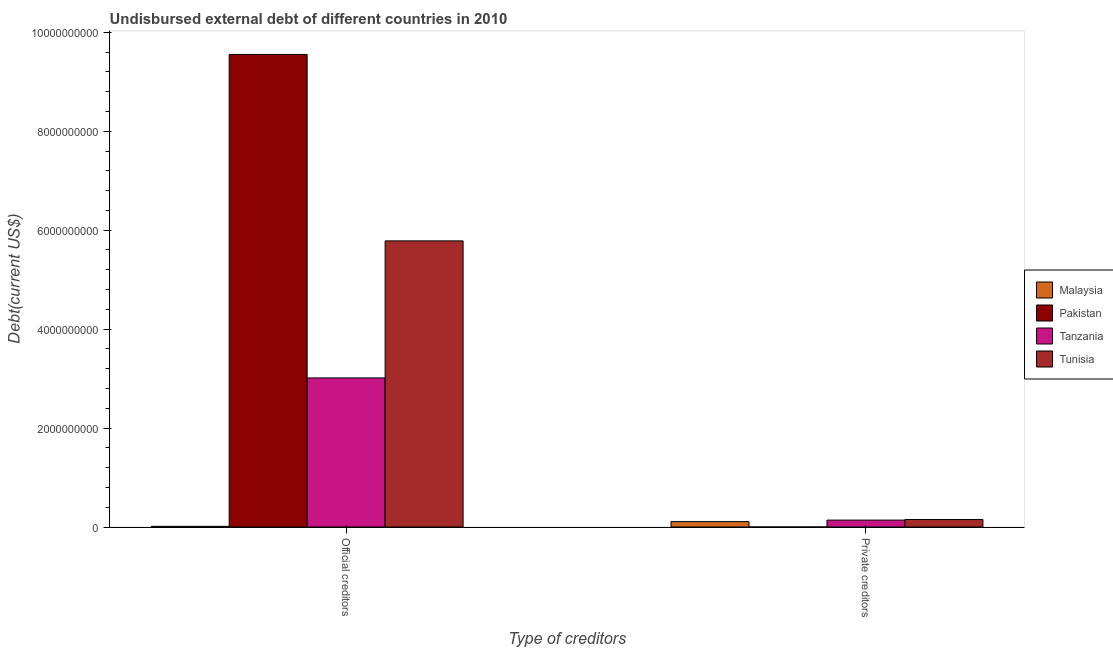How many different coloured bars are there?
Your answer should be compact. 4. How many bars are there on the 2nd tick from the right?
Make the answer very short. 4. What is the label of the 1st group of bars from the left?
Give a very brief answer. Official creditors. What is the undisbursed external debt of official creditors in Tunisia?
Make the answer very short. 5.78e+09. Across all countries, what is the maximum undisbursed external debt of official creditors?
Offer a terse response. 9.55e+09. Across all countries, what is the minimum undisbursed external debt of private creditors?
Make the answer very short. 2.18e+05. In which country was the undisbursed external debt of official creditors minimum?
Offer a very short reply. Malaysia. What is the total undisbursed external debt of official creditors in the graph?
Make the answer very short. 1.84e+1. What is the difference between the undisbursed external debt of official creditors in Tanzania and that in Malaysia?
Offer a terse response. 3.00e+09. What is the difference between the undisbursed external debt of official creditors in Malaysia and the undisbursed external debt of private creditors in Tanzania?
Keep it short and to the point. -1.26e+08. What is the average undisbursed external debt of private creditors per country?
Offer a terse response. 1.00e+08. What is the difference between the undisbursed external debt of private creditors and undisbursed external debt of official creditors in Tunisia?
Provide a succinct answer. -5.63e+09. What is the ratio of the undisbursed external debt of private creditors in Tanzania to that in Malaysia?
Offer a terse response. 1.28. What does the 1st bar from the left in Private creditors represents?
Make the answer very short. Malaysia. How many bars are there?
Offer a very short reply. 8. How many countries are there in the graph?
Your answer should be compact. 4. What is the difference between two consecutive major ticks on the Y-axis?
Ensure brevity in your answer.  2.00e+09. Does the graph contain any zero values?
Provide a short and direct response. No. How are the legend labels stacked?
Your answer should be very brief. Vertical. What is the title of the graph?
Your answer should be very brief. Undisbursed external debt of different countries in 2010. What is the label or title of the X-axis?
Provide a succinct answer. Type of creditors. What is the label or title of the Y-axis?
Provide a short and direct response. Debt(current US$). What is the Debt(current US$) in Malaysia in Official creditors?
Ensure brevity in your answer.  1.37e+07. What is the Debt(current US$) of Pakistan in Official creditors?
Offer a terse response. 9.55e+09. What is the Debt(current US$) in Tanzania in Official creditors?
Your answer should be very brief. 3.01e+09. What is the Debt(current US$) of Tunisia in Official creditors?
Provide a short and direct response. 5.78e+09. What is the Debt(current US$) of Malaysia in Private creditors?
Offer a very short reply. 1.09e+08. What is the Debt(current US$) in Pakistan in Private creditors?
Make the answer very short. 2.18e+05. What is the Debt(current US$) in Tanzania in Private creditors?
Keep it short and to the point. 1.40e+08. What is the Debt(current US$) in Tunisia in Private creditors?
Your response must be concise. 1.52e+08. Across all Type of creditors, what is the maximum Debt(current US$) of Malaysia?
Provide a succinct answer. 1.09e+08. Across all Type of creditors, what is the maximum Debt(current US$) in Pakistan?
Ensure brevity in your answer.  9.55e+09. Across all Type of creditors, what is the maximum Debt(current US$) of Tanzania?
Make the answer very short. 3.01e+09. Across all Type of creditors, what is the maximum Debt(current US$) of Tunisia?
Make the answer very short. 5.78e+09. Across all Type of creditors, what is the minimum Debt(current US$) in Malaysia?
Offer a very short reply. 1.37e+07. Across all Type of creditors, what is the minimum Debt(current US$) of Pakistan?
Ensure brevity in your answer.  2.18e+05. Across all Type of creditors, what is the minimum Debt(current US$) of Tanzania?
Provide a short and direct response. 1.40e+08. Across all Type of creditors, what is the minimum Debt(current US$) of Tunisia?
Provide a short and direct response. 1.52e+08. What is the total Debt(current US$) of Malaysia in the graph?
Provide a short and direct response. 1.23e+08. What is the total Debt(current US$) in Pakistan in the graph?
Make the answer very short. 9.55e+09. What is the total Debt(current US$) in Tanzania in the graph?
Keep it short and to the point. 3.15e+09. What is the total Debt(current US$) of Tunisia in the graph?
Provide a succinct answer. 5.94e+09. What is the difference between the Debt(current US$) in Malaysia in Official creditors and that in Private creditors?
Make the answer very short. -9.54e+07. What is the difference between the Debt(current US$) in Pakistan in Official creditors and that in Private creditors?
Your answer should be compact. 9.55e+09. What is the difference between the Debt(current US$) of Tanzania in Official creditors and that in Private creditors?
Make the answer very short. 2.87e+09. What is the difference between the Debt(current US$) of Tunisia in Official creditors and that in Private creditors?
Provide a succinct answer. 5.63e+09. What is the difference between the Debt(current US$) of Malaysia in Official creditors and the Debt(current US$) of Pakistan in Private creditors?
Provide a short and direct response. 1.35e+07. What is the difference between the Debt(current US$) in Malaysia in Official creditors and the Debt(current US$) in Tanzania in Private creditors?
Your answer should be very brief. -1.26e+08. What is the difference between the Debt(current US$) in Malaysia in Official creditors and the Debt(current US$) in Tunisia in Private creditors?
Ensure brevity in your answer.  -1.39e+08. What is the difference between the Debt(current US$) of Pakistan in Official creditors and the Debt(current US$) of Tanzania in Private creditors?
Ensure brevity in your answer.  9.41e+09. What is the difference between the Debt(current US$) in Pakistan in Official creditors and the Debt(current US$) in Tunisia in Private creditors?
Your answer should be very brief. 9.40e+09. What is the difference between the Debt(current US$) of Tanzania in Official creditors and the Debt(current US$) of Tunisia in Private creditors?
Offer a terse response. 2.86e+09. What is the average Debt(current US$) in Malaysia per Type of creditors?
Provide a short and direct response. 6.14e+07. What is the average Debt(current US$) in Pakistan per Type of creditors?
Provide a succinct answer. 4.78e+09. What is the average Debt(current US$) in Tanzania per Type of creditors?
Your answer should be very brief. 1.58e+09. What is the average Debt(current US$) of Tunisia per Type of creditors?
Provide a succinct answer. 2.97e+09. What is the difference between the Debt(current US$) in Malaysia and Debt(current US$) in Pakistan in Official creditors?
Provide a short and direct response. -9.54e+09. What is the difference between the Debt(current US$) of Malaysia and Debt(current US$) of Tanzania in Official creditors?
Ensure brevity in your answer.  -3.00e+09. What is the difference between the Debt(current US$) of Malaysia and Debt(current US$) of Tunisia in Official creditors?
Offer a terse response. -5.77e+09. What is the difference between the Debt(current US$) of Pakistan and Debt(current US$) of Tanzania in Official creditors?
Make the answer very short. 6.54e+09. What is the difference between the Debt(current US$) in Pakistan and Debt(current US$) in Tunisia in Official creditors?
Provide a succinct answer. 3.77e+09. What is the difference between the Debt(current US$) of Tanzania and Debt(current US$) of Tunisia in Official creditors?
Keep it short and to the point. -2.77e+09. What is the difference between the Debt(current US$) of Malaysia and Debt(current US$) of Pakistan in Private creditors?
Keep it short and to the point. 1.09e+08. What is the difference between the Debt(current US$) in Malaysia and Debt(current US$) in Tanzania in Private creditors?
Your response must be concise. -3.06e+07. What is the difference between the Debt(current US$) of Malaysia and Debt(current US$) of Tunisia in Private creditors?
Keep it short and to the point. -4.33e+07. What is the difference between the Debt(current US$) of Pakistan and Debt(current US$) of Tanzania in Private creditors?
Offer a terse response. -1.39e+08. What is the difference between the Debt(current US$) in Pakistan and Debt(current US$) in Tunisia in Private creditors?
Offer a very short reply. -1.52e+08. What is the difference between the Debt(current US$) of Tanzania and Debt(current US$) of Tunisia in Private creditors?
Your answer should be very brief. -1.27e+07. What is the ratio of the Debt(current US$) of Malaysia in Official creditors to that in Private creditors?
Your answer should be very brief. 0.13. What is the ratio of the Debt(current US$) in Pakistan in Official creditors to that in Private creditors?
Keep it short and to the point. 4.38e+04. What is the ratio of the Debt(current US$) in Tanzania in Official creditors to that in Private creditors?
Offer a terse response. 21.58. What is the ratio of the Debt(current US$) in Tunisia in Official creditors to that in Private creditors?
Your answer should be compact. 37.96. What is the difference between the highest and the second highest Debt(current US$) of Malaysia?
Provide a short and direct response. 9.54e+07. What is the difference between the highest and the second highest Debt(current US$) in Pakistan?
Your answer should be very brief. 9.55e+09. What is the difference between the highest and the second highest Debt(current US$) of Tanzania?
Provide a succinct answer. 2.87e+09. What is the difference between the highest and the second highest Debt(current US$) of Tunisia?
Provide a succinct answer. 5.63e+09. What is the difference between the highest and the lowest Debt(current US$) of Malaysia?
Offer a very short reply. 9.54e+07. What is the difference between the highest and the lowest Debt(current US$) of Pakistan?
Offer a very short reply. 9.55e+09. What is the difference between the highest and the lowest Debt(current US$) in Tanzania?
Offer a terse response. 2.87e+09. What is the difference between the highest and the lowest Debt(current US$) in Tunisia?
Your response must be concise. 5.63e+09. 